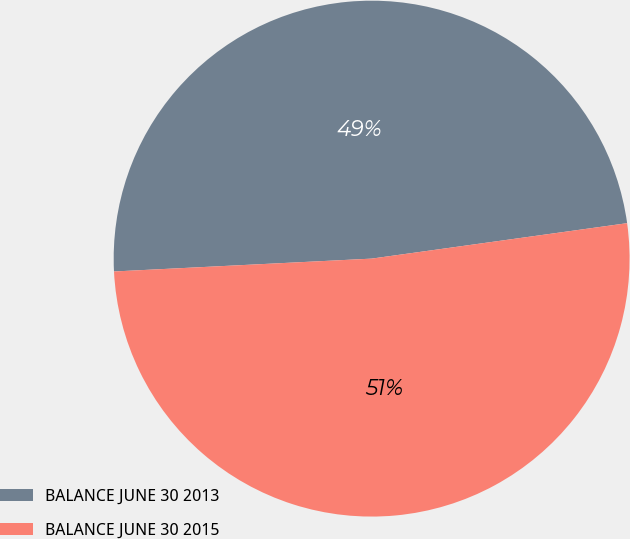Convert chart. <chart><loc_0><loc_0><loc_500><loc_500><pie_chart><fcel>BALANCE JUNE 30 2013<fcel>BALANCE JUNE 30 2015<nl><fcel>48.6%<fcel>51.4%<nl></chart> 